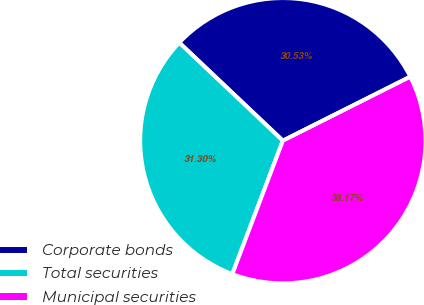Convert chart. <chart><loc_0><loc_0><loc_500><loc_500><pie_chart><fcel>Corporate bonds<fcel>Total securities<fcel>Municipal securities<nl><fcel>30.53%<fcel>31.3%<fcel>38.17%<nl></chart> 